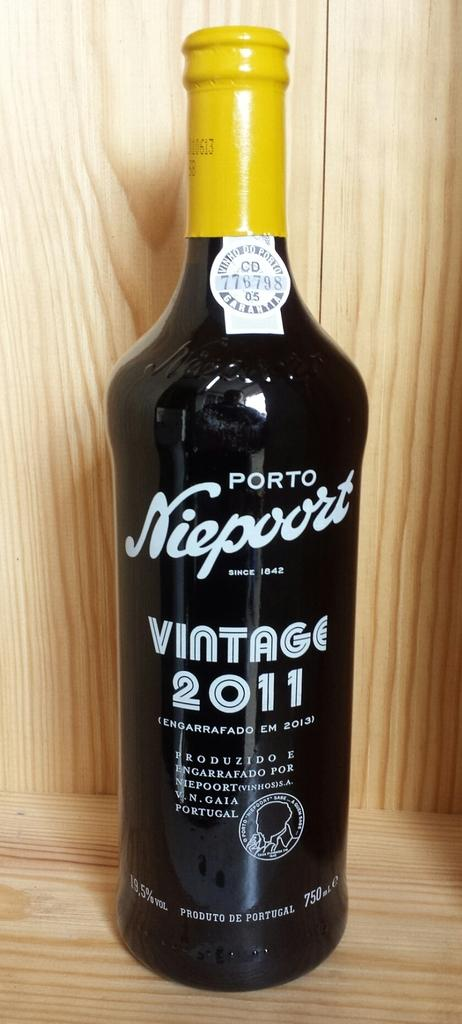<image>
Render a clear and concise summary of the photo. the year 2011 is on the front of a bottle 